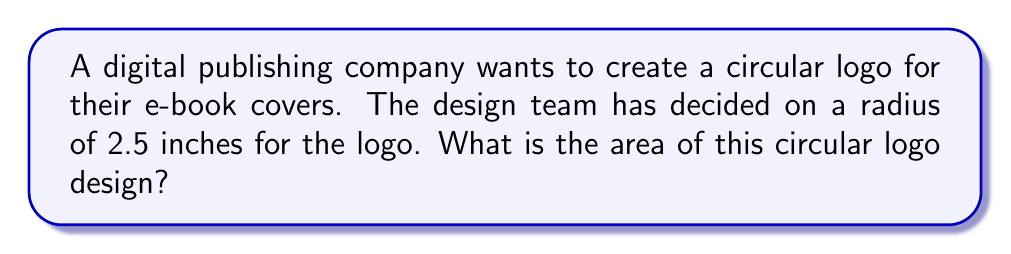What is the answer to this math problem? To find the area of a circular logo, we use the formula for the area of a circle:

$$A = \pi r^2$$

Where:
$A$ = area of the circle
$\pi$ = pi (approximately 3.14159)
$r$ = radius of the circle

Given:
$r = 2.5$ inches

Let's substitute these values into the formula:

$$A = \pi (2.5)^2$$

Now, let's calculate step-by-step:

1. Square the radius:
   $$(2.5)^2 = 6.25$$

2. Multiply by $\pi$:
   $$A = \pi \cdot 6.25$$
   $$A \approx 3.14159 \cdot 6.25$$
   $$A \approx 19.6349375$$

3. Round to two decimal places:
   $$A \approx 19.63 \text{ square inches}$$

Therefore, the area of the circular logo design is approximately 19.63 square inches.
Answer: $19.63 \text{ in}^2$ 